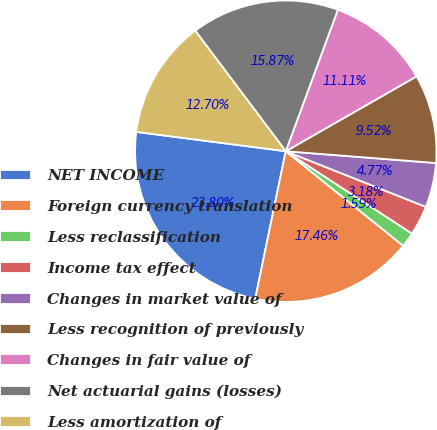Convert chart. <chart><loc_0><loc_0><loc_500><loc_500><pie_chart><fcel>NET INCOME<fcel>Foreign currency translation<fcel>Less reclassification<fcel>Income tax effect<fcel>Changes in market value of<fcel>Less recognition of previously<fcel>Changes in fair value of<fcel>Net actuarial gains (losses)<fcel>Less amortization of<nl><fcel>23.8%<fcel>17.46%<fcel>1.59%<fcel>3.18%<fcel>4.77%<fcel>9.52%<fcel>11.11%<fcel>15.87%<fcel>12.7%<nl></chart> 